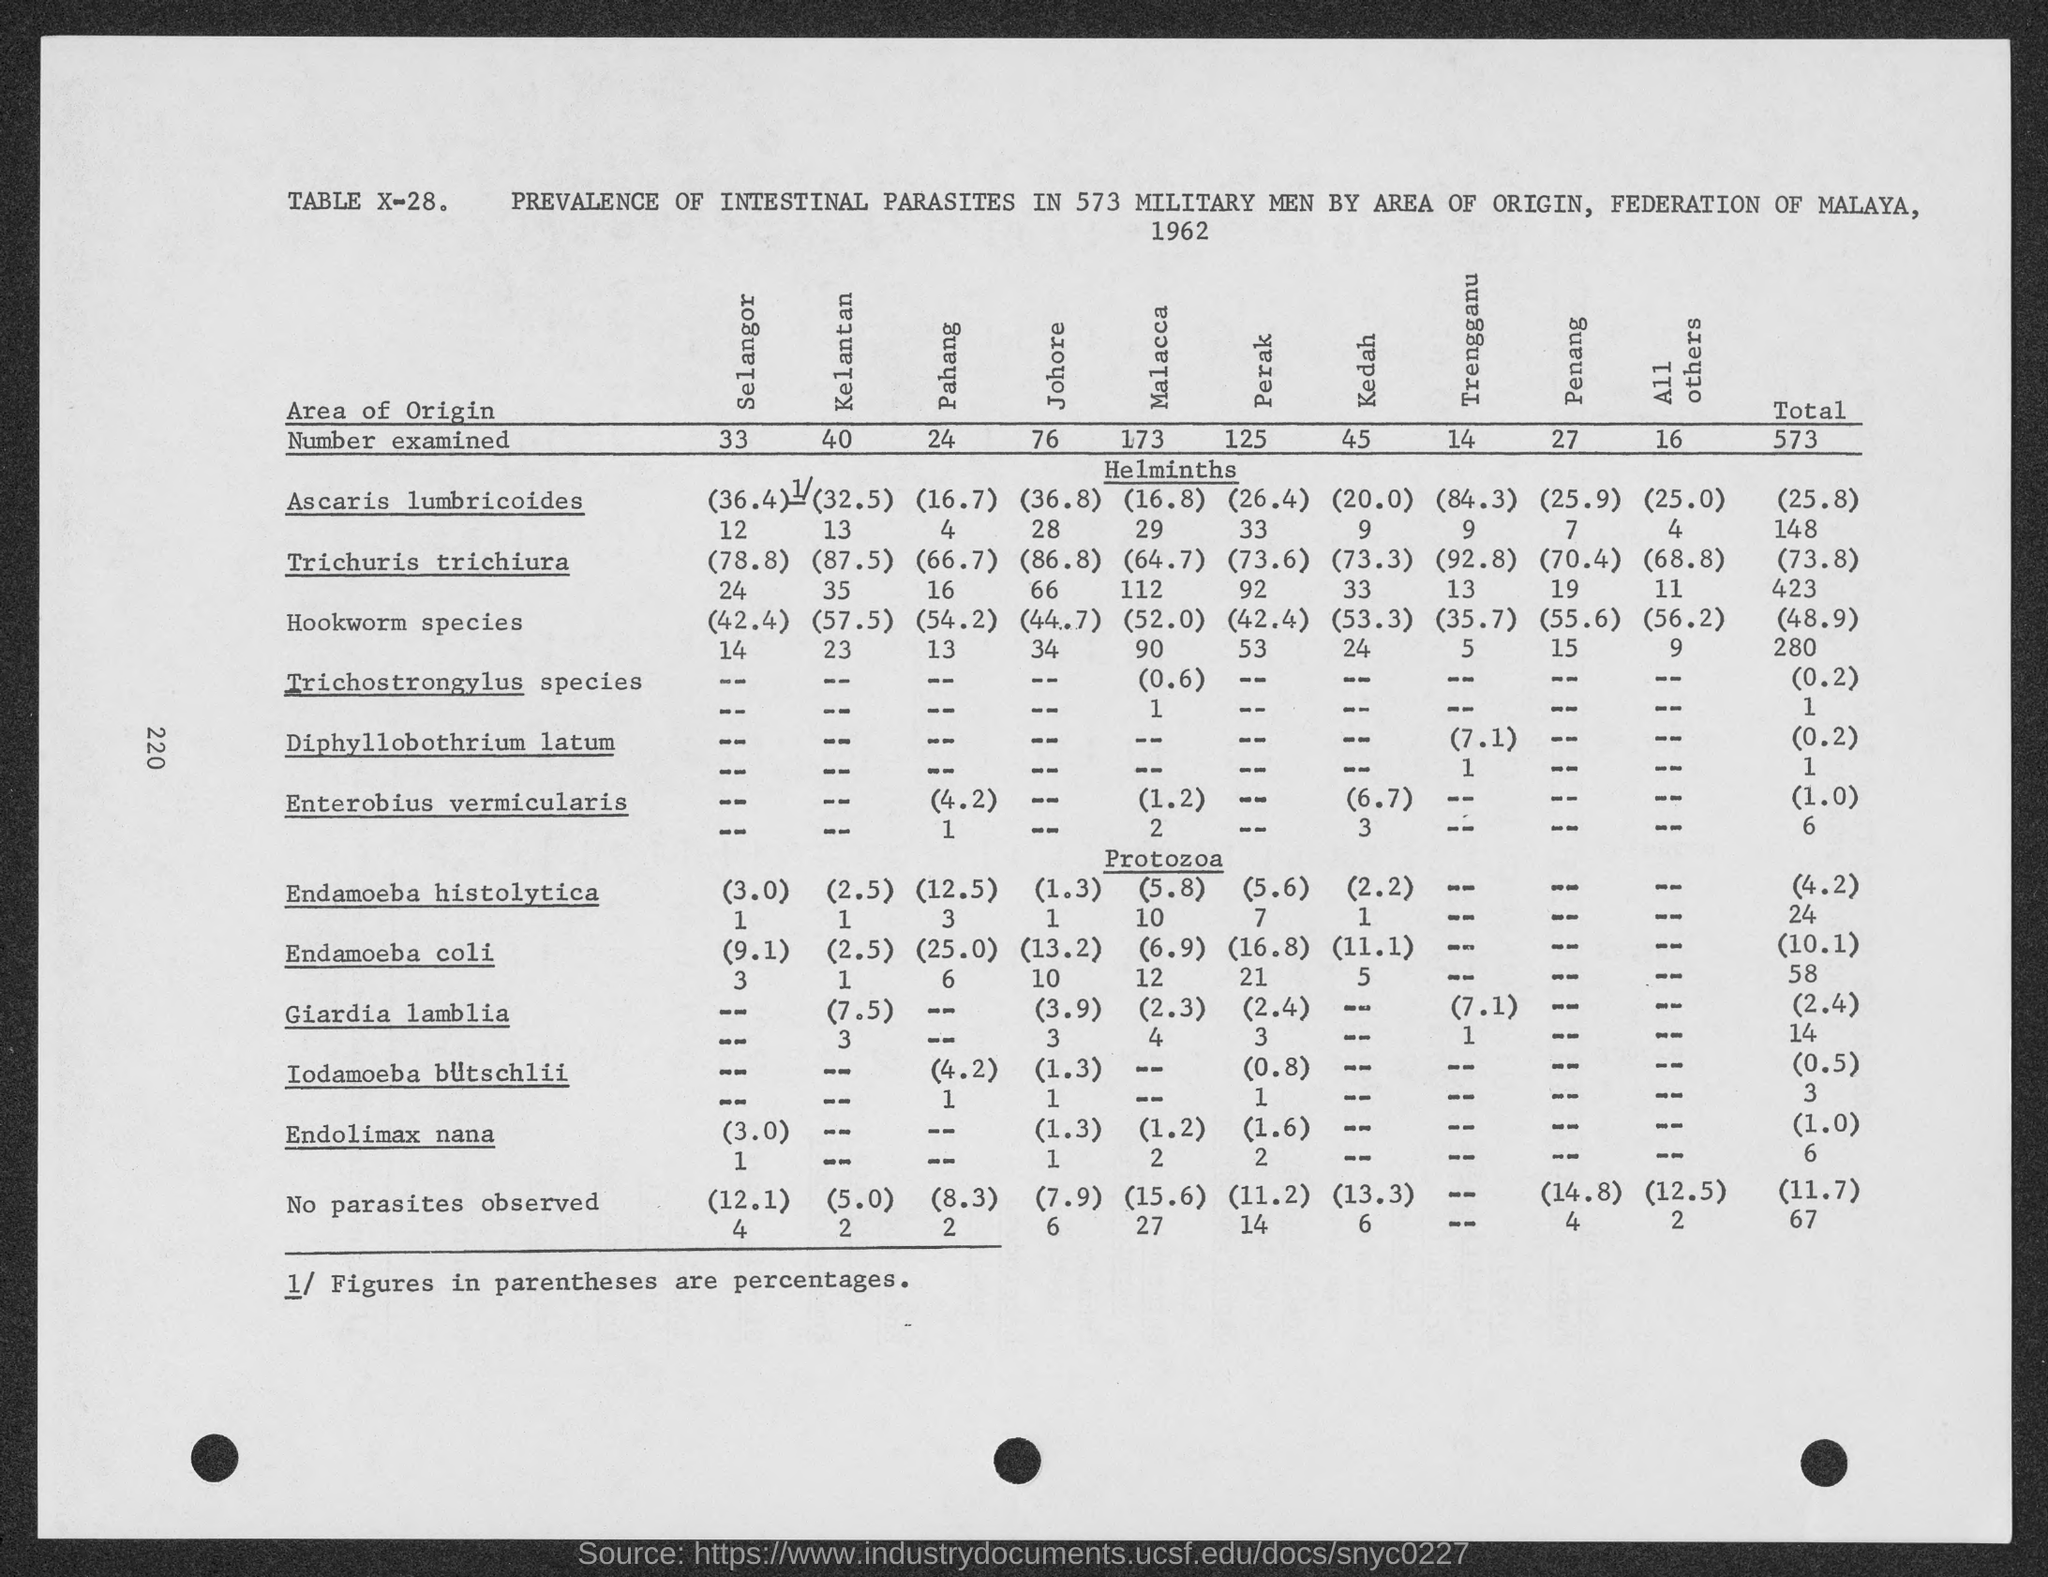Point out several critical features in this image. The total number of examinations that have been conducted is 573. In Kelantan, the number of examined patients is 40. The number being examined in Kedah is 45. The number examined in Malacca is 173. The number that is being examined in Trengganu is 14. 